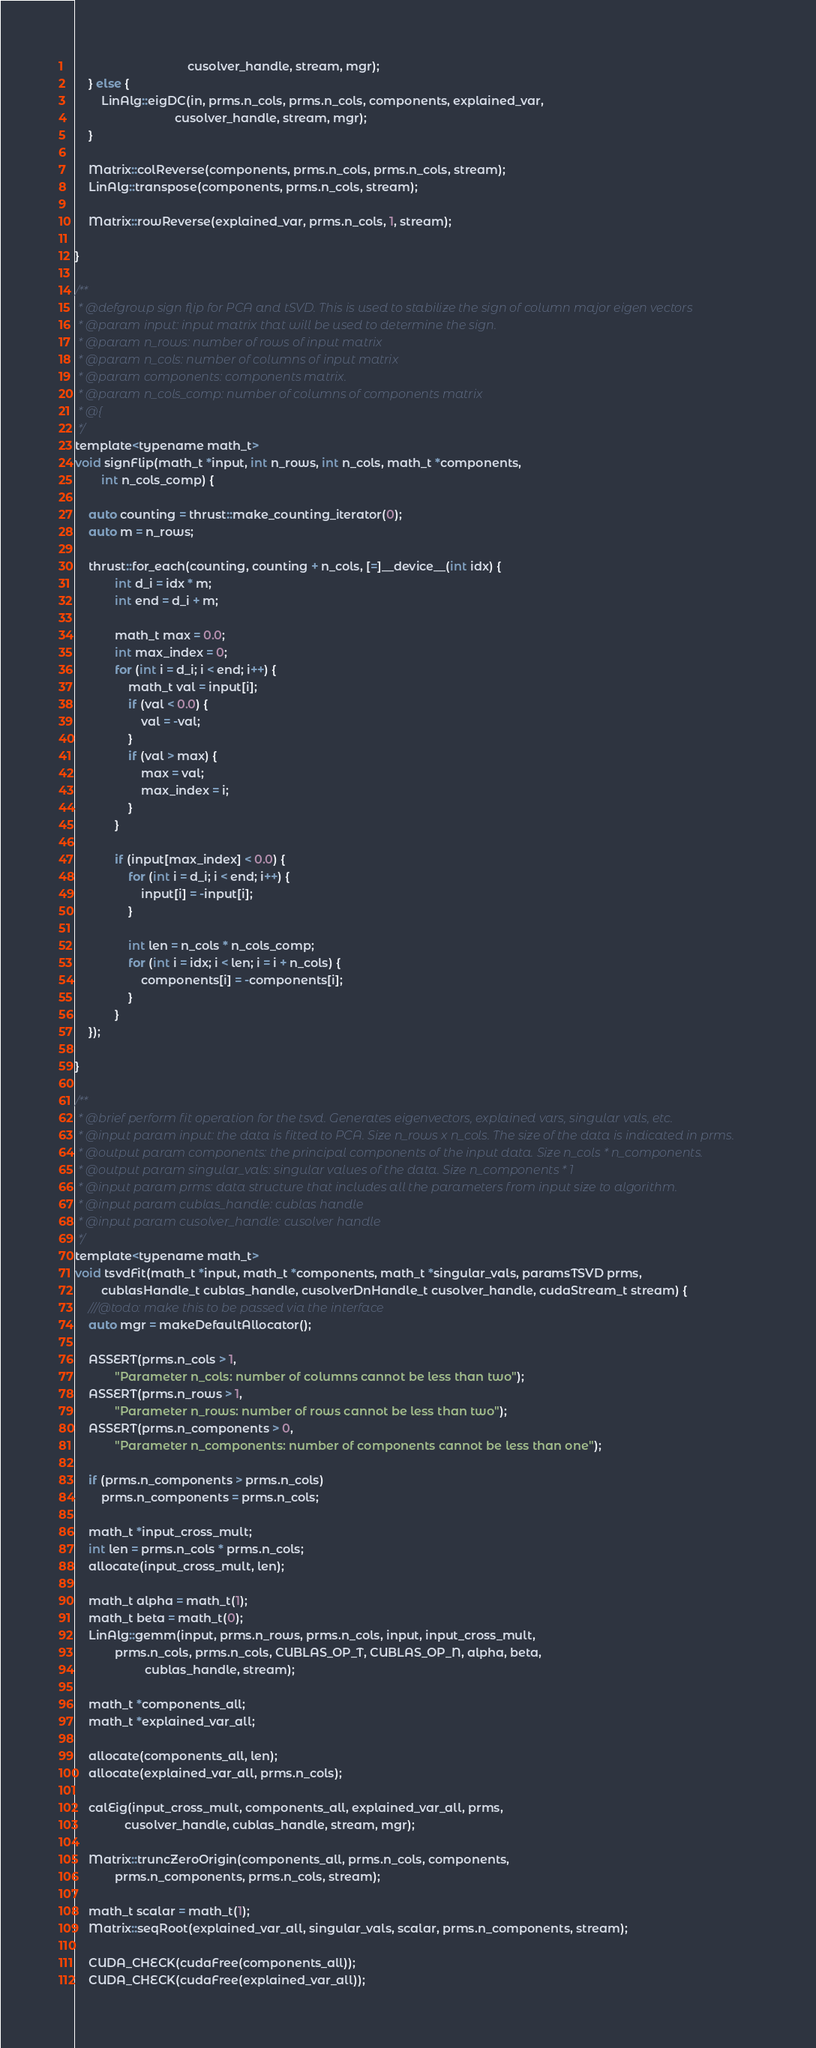<code> <loc_0><loc_0><loc_500><loc_500><_C_>                                  cusolver_handle, stream, mgr);
	} else {
		LinAlg::eigDC(in, prms.n_cols, prms.n_cols, components, explained_var,
                              cusolver_handle, stream, mgr);
	}

	Matrix::colReverse(components, prms.n_cols, prms.n_cols, stream);
	LinAlg::transpose(components, prms.n_cols, stream);

	Matrix::rowReverse(explained_var, prms.n_cols, 1, stream);

}

/**
 * @defgroup sign flip for PCA and tSVD. This is used to stabilize the sign of column major eigen vectors
 * @param input: input matrix that will be used to determine the sign.
 * @param n_rows: number of rows of input matrix
 * @param n_cols: number of columns of input matrix
 * @param components: components matrix.
 * @param n_cols_comp: number of columns of components matrix
 * @{
 */
template<typename math_t>
void signFlip(math_t *input, int n_rows, int n_cols, math_t *components,
		int n_cols_comp) {

	auto counting = thrust::make_counting_iterator(0);
	auto m = n_rows;

    thrust::for_each(counting, counting + n_cols, [=]__device__(int idx) {
			int d_i = idx * m;
			int end = d_i + m;

			math_t max = 0.0;
			int max_index = 0;
			for (int i = d_i; i < end; i++) {
				math_t val = input[i];
				if (val < 0.0) {
					val = -val;
				}
				if (val > max) {
					max = val;
					max_index = i;
				}
			}

			if (input[max_index] < 0.0) {
				for (int i = d_i; i < end; i++) {
					input[i] = -input[i];
				}

				int len = n_cols * n_cols_comp;
				for (int i = idx; i < len; i = i + n_cols) {
					components[i] = -components[i];
				}
			}
	});

}

/**
 * @brief perform fit operation for the tsvd. Generates eigenvectors, explained vars, singular vals, etc.
 * @input param input: the data is fitted to PCA. Size n_rows x n_cols. The size of the data is indicated in prms.
 * @output param components: the principal components of the input data. Size n_cols * n_components.
 * @output param singular_vals: singular values of the data. Size n_components * 1
 * @input param prms: data structure that includes all the parameters from input size to algorithm.
 * @input param cublas_handle: cublas handle
 * @input param cusolver_handle: cusolver handle
 */
template<typename math_t>
void tsvdFit(math_t *input, math_t *components, math_t *singular_vals, paramsTSVD prms,
		cublasHandle_t cublas_handle, cusolverDnHandle_t cusolver_handle, cudaStream_t stream) {
    ///@todo: make this to be passed via the interface
    auto mgr = makeDefaultAllocator();

	ASSERT(prms.n_cols > 1,
			"Parameter n_cols: number of columns cannot be less than two");
	ASSERT(prms.n_rows > 1,
			"Parameter n_rows: number of rows cannot be less than two");
	ASSERT(prms.n_components > 0,
			"Parameter n_components: number of components cannot be less than one");

	if (prms.n_components > prms.n_cols)
		prms.n_components = prms.n_cols;

	math_t *input_cross_mult;
	int len = prms.n_cols * prms.n_cols;
	allocate(input_cross_mult, len);

	math_t alpha = math_t(1);
	math_t beta = math_t(0);
	LinAlg::gemm(input, prms.n_rows, prms.n_cols, input, input_cross_mult,
			prms.n_cols, prms.n_cols, CUBLAS_OP_T, CUBLAS_OP_N, alpha, beta,
                     cublas_handle, stream);

	math_t *components_all;
	math_t *explained_var_all;

	allocate(components_all, len);
	allocate(explained_var_all, prms.n_cols);

	calEig(input_cross_mult, components_all, explained_var_all, prms,
               cusolver_handle, cublas_handle, stream, mgr);

	Matrix::truncZeroOrigin(components_all, prms.n_cols, components,
			prms.n_components, prms.n_cols, stream);

	math_t scalar = math_t(1);
	Matrix::seqRoot(explained_var_all, singular_vals, scalar, prms.n_components, stream);

	CUDA_CHECK(cudaFree(components_all));
	CUDA_CHECK(cudaFree(explained_var_all));</code> 